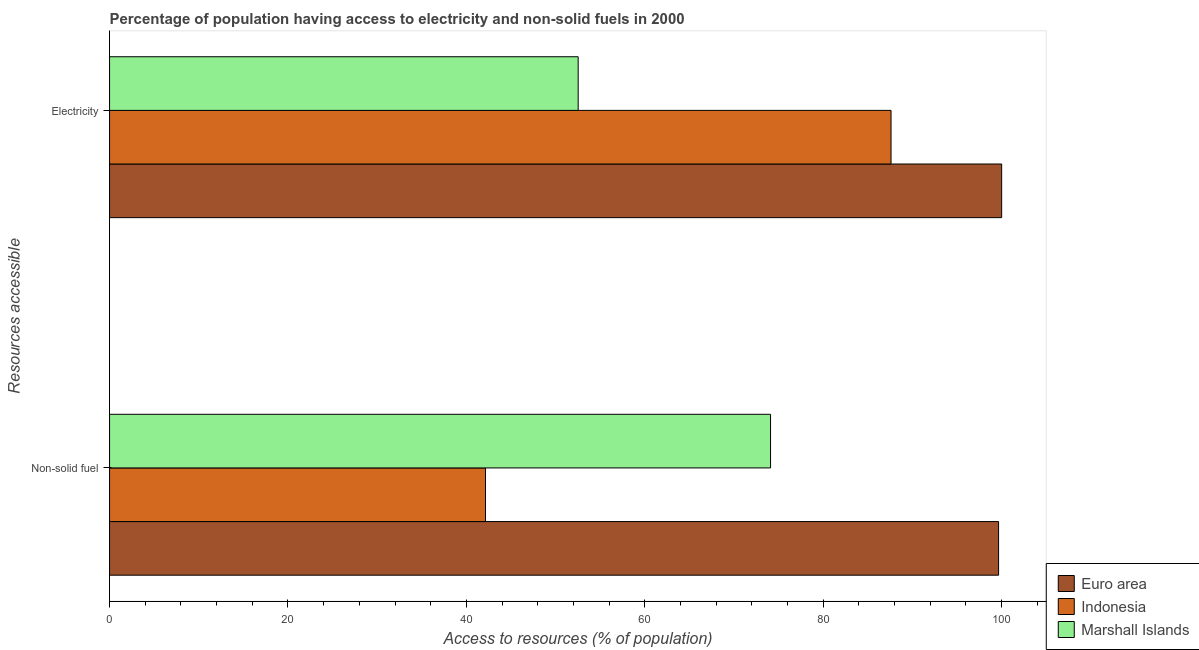How many different coloured bars are there?
Ensure brevity in your answer.  3. How many groups of bars are there?
Give a very brief answer. 2. Are the number of bars per tick equal to the number of legend labels?
Your answer should be very brief. Yes. What is the label of the 1st group of bars from the top?
Keep it short and to the point. Electricity. What is the percentage of population having access to electricity in Marshall Islands?
Make the answer very short. 52.53. Across all countries, what is the maximum percentage of population having access to non-solid fuel?
Make the answer very short. 99.66. Across all countries, what is the minimum percentage of population having access to non-solid fuel?
Provide a short and direct response. 42.14. In which country was the percentage of population having access to electricity minimum?
Keep it short and to the point. Marshall Islands. What is the total percentage of population having access to non-solid fuel in the graph?
Keep it short and to the point. 215.89. What is the difference between the percentage of population having access to electricity in Marshall Islands and that in Indonesia?
Your response must be concise. -35.07. What is the difference between the percentage of population having access to electricity in Marshall Islands and the percentage of population having access to non-solid fuel in Indonesia?
Make the answer very short. 10.39. What is the average percentage of population having access to non-solid fuel per country?
Provide a short and direct response. 71.96. What is the difference between the percentage of population having access to electricity and percentage of population having access to non-solid fuel in Indonesia?
Provide a succinct answer. 45.46. What is the ratio of the percentage of population having access to electricity in Euro area to that in Marshall Islands?
Your response must be concise. 1.9. Is the percentage of population having access to non-solid fuel in Euro area less than that in Marshall Islands?
Offer a terse response. No. What does the 3rd bar from the top in Electricity represents?
Provide a succinct answer. Euro area. What does the 3rd bar from the bottom in Non-solid fuel represents?
Make the answer very short. Marshall Islands. What is the difference between two consecutive major ticks on the X-axis?
Offer a terse response. 20. Does the graph contain any zero values?
Give a very brief answer. No. Where does the legend appear in the graph?
Offer a terse response. Bottom right. What is the title of the graph?
Provide a succinct answer. Percentage of population having access to electricity and non-solid fuels in 2000. Does "Vietnam" appear as one of the legend labels in the graph?
Provide a succinct answer. No. What is the label or title of the X-axis?
Your response must be concise. Access to resources (% of population). What is the label or title of the Y-axis?
Make the answer very short. Resources accessible. What is the Access to resources (% of population) in Euro area in Non-solid fuel?
Make the answer very short. 99.66. What is the Access to resources (% of population) of Indonesia in Non-solid fuel?
Your response must be concise. 42.14. What is the Access to resources (% of population) of Marshall Islands in Non-solid fuel?
Give a very brief answer. 74.09. What is the Access to resources (% of population) of Euro area in Electricity?
Provide a short and direct response. 100. What is the Access to resources (% of population) in Indonesia in Electricity?
Your answer should be very brief. 87.6. What is the Access to resources (% of population) in Marshall Islands in Electricity?
Offer a terse response. 52.53. Across all Resources accessible, what is the maximum Access to resources (% of population) in Euro area?
Provide a succinct answer. 100. Across all Resources accessible, what is the maximum Access to resources (% of population) of Indonesia?
Make the answer very short. 87.6. Across all Resources accessible, what is the maximum Access to resources (% of population) of Marshall Islands?
Provide a short and direct response. 74.09. Across all Resources accessible, what is the minimum Access to resources (% of population) in Euro area?
Offer a terse response. 99.66. Across all Resources accessible, what is the minimum Access to resources (% of population) in Indonesia?
Give a very brief answer. 42.14. Across all Resources accessible, what is the minimum Access to resources (% of population) of Marshall Islands?
Your answer should be very brief. 52.53. What is the total Access to resources (% of population) in Euro area in the graph?
Give a very brief answer. 199.66. What is the total Access to resources (% of population) in Indonesia in the graph?
Offer a terse response. 129.74. What is the total Access to resources (% of population) of Marshall Islands in the graph?
Ensure brevity in your answer.  126.62. What is the difference between the Access to resources (% of population) of Euro area in Non-solid fuel and that in Electricity?
Your answer should be compact. -0.34. What is the difference between the Access to resources (% of population) of Indonesia in Non-solid fuel and that in Electricity?
Your response must be concise. -45.46. What is the difference between the Access to resources (% of population) of Marshall Islands in Non-solid fuel and that in Electricity?
Ensure brevity in your answer.  21.56. What is the difference between the Access to resources (% of population) of Euro area in Non-solid fuel and the Access to resources (% of population) of Indonesia in Electricity?
Provide a short and direct response. 12.06. What is the difference between the Access to resources (% of population) of Euro area in Non-solid fuel and the Access to resources (% of population) of Marshall Islands in Electricity?
Keep it short and to the point. 47.12. What is the difference between the Access to resources (% of population) of Indonesia in Non-solid fuel and the Access to resources (% of population) of Marshall Islands in Electricity?
Your response must be concise. -10.39. What is the average Access to resources (% of population) of Euro area per Resources accessible?
Ensure brevity in your answer.  99.83. What is the average Access to resources (% of population) in Indonesia per Resources accessible?
Provide a succinct answer. 64.87. What is the average Access to resources (% of population) of Marshall Islands per Resources accessible?
Give a very brief answer. 63.31. What is the difference between the Access to resources (% of population) in Euro area and Access to resources (% of population) in Indonesia in Non-solid fuel?
Provide a short and direct response. 57.51. What is the difference between the Access to resources (% of population) of Euro area and Access to resources (% of population) of Marshall Islands in Non-solid fuel?
Keep it short and to the point. 25.56. What is the difference between the Access to resources (% of population) in Indonesia and Access to resources (% of population) in Marshall Islands in Non-solid fuel?
Provide a short and direct response. -31.95. What is the difference between the Access to resources (% of population) in Euro area and Access to resources (% of population) in Indonesia in Electricity?
Offer a terse response. 12.4. What is the difference between the Access to resources (% of population) of Euro area and Access to resources (% of population) of Marshall Islands in Electricity?
Your answer should be very brief. 47.47. What is the difference between the Access to resources (% of population) of Indonesia and Access to resources (% of population) of Marshall Islands in Electricity?
Provide a short and direct response. 35.07. What is the ratio of the Access to resources (% of population) of Euro area in Non-solid fuel to that in Electricity?
Your response must be concise. 1. What is the ratio of the Access to resources (% of population) in Indonesia in Non-solid fuel to that in Electricity?
Make the answer very short. 0.48. What is the ratio of the Access to resources (% of population) in Marshall Islands in Non-solid fuel to that in Electricity?
Give a very brief answer. 1.41. What is the difference between the highest and the second highest Access to resources (% of population) in Euro area?
Offer a very short reply. 0.34. What is the difference between the highest and the second highest Access to resources (% of population) in Indonesia?
Make the answer very short. 45.46. What is the difference between the highest and the second highest Access to resources (% of population) of Marshall Islands?
Provide a succinct answer. 21.56. What is the difference between the highest and the lowest Access to resources (% of population) of Euro area?
Provide a short and direct response. 0.34. What is the difference between the highest and the lowest Access to resources (% of population) of Indonesia?
Your answer should be very brief. 45.46. What is the difference between the highest and the lowest Access to resources (% of population) in Marshall Islands?
Keep it short and to the point. 21.56. 